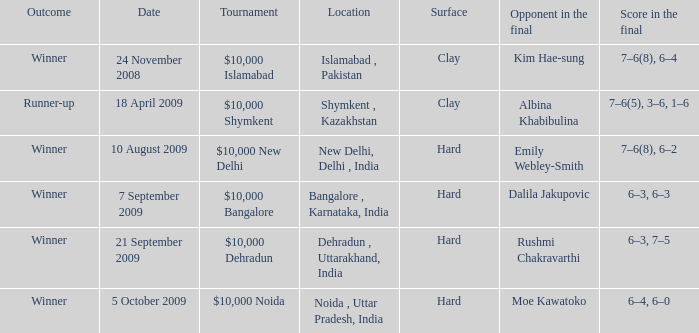What is the name of the tournament where outcome is runner-up $10,000 Shymkent. 